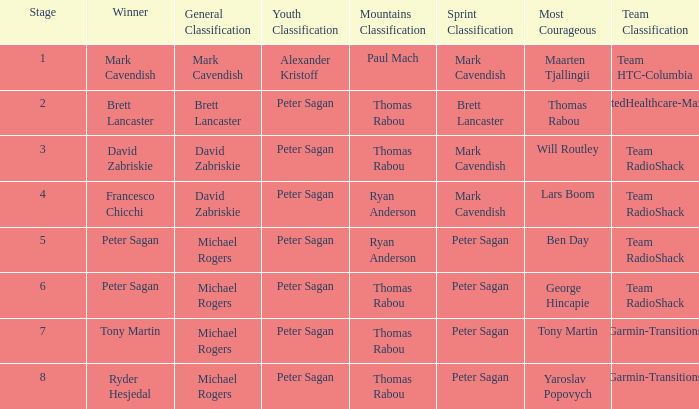When Peter Sagan won the youth classification and Thomas Rabou won the most corageous, who won the sprint classification? Brett Lancaster. 